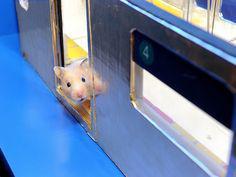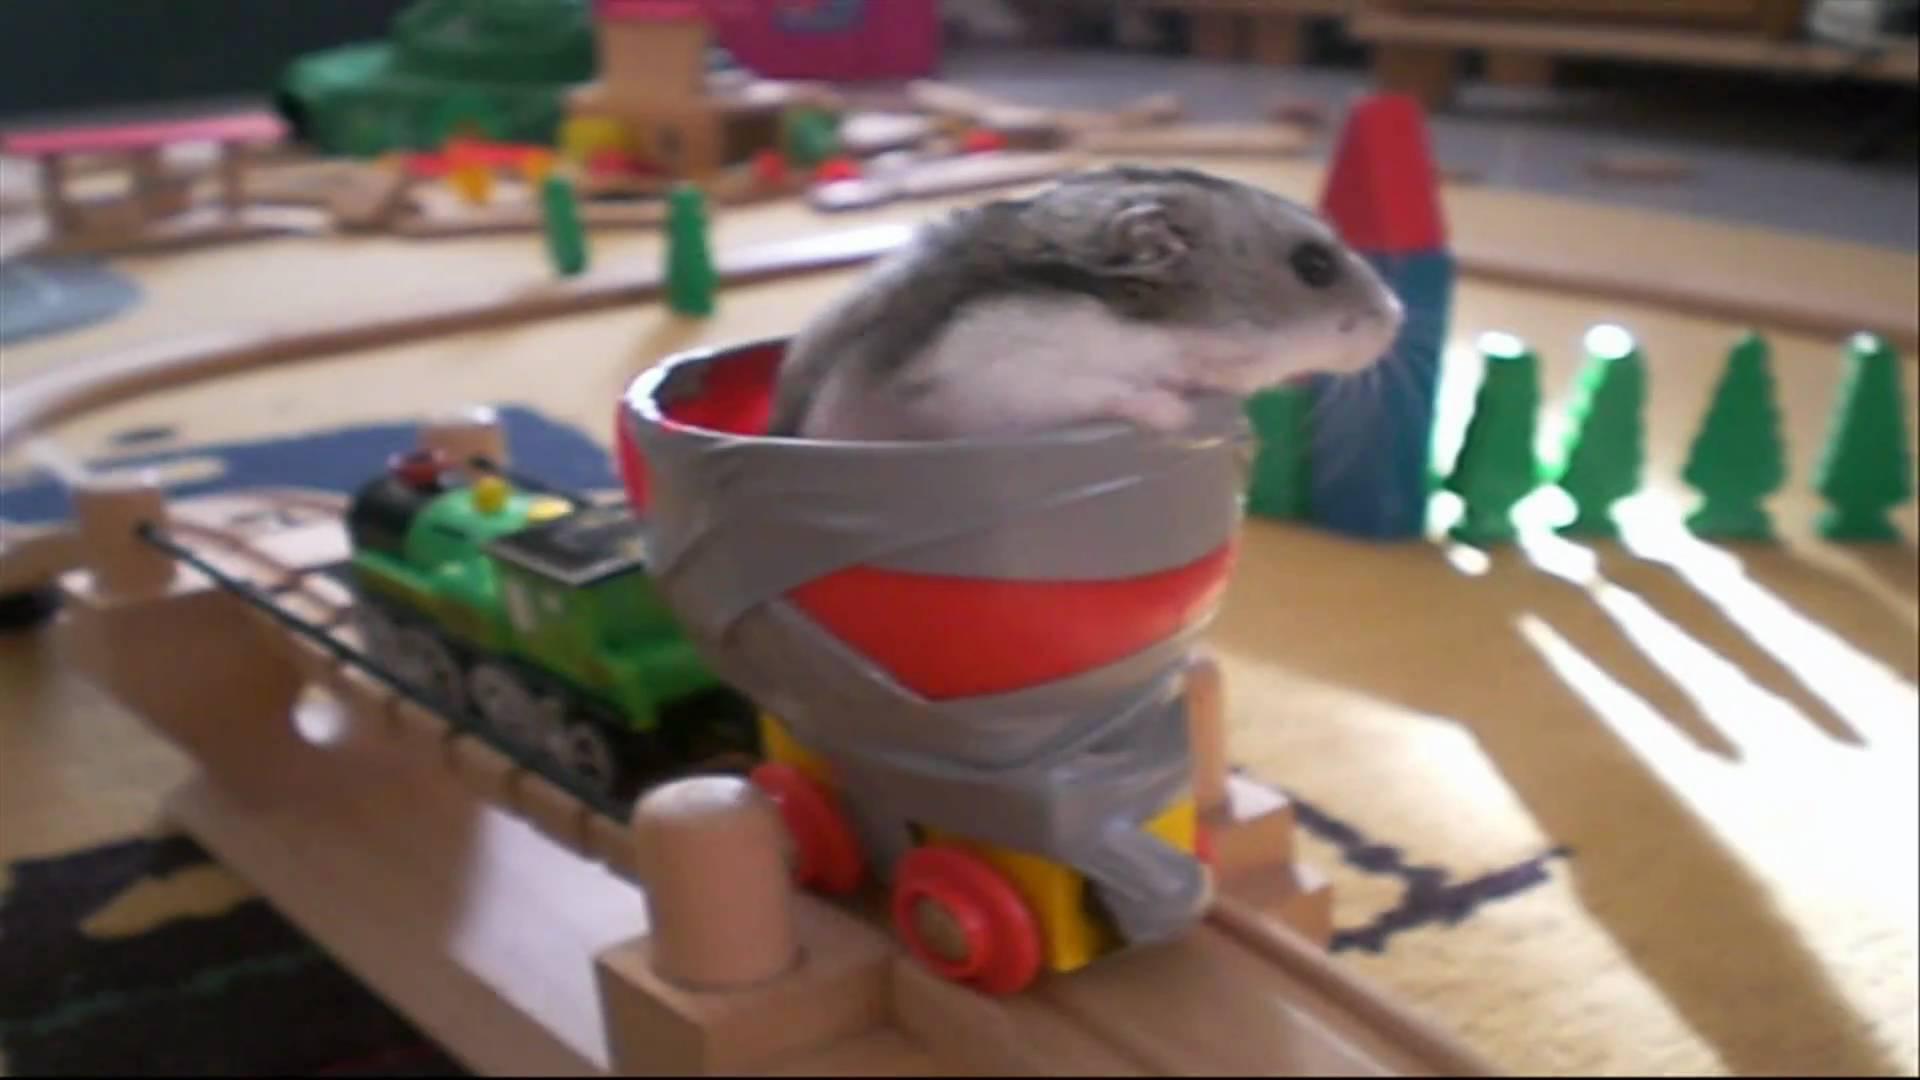The first image is the image on the left, the second image is the image on the right. Given the left and right images, does the statement "1 hamster is in the doorway of a toy train car." hold true? Answer yes or no. Yes. The first image is the image on the left, the second image is the image on the right. For the images shown, is this caption "There are two mice near yellow and orange seats." true? Answer yes or no. No. 